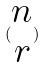<formula> <loc_0><loc_0><loc_500><loc_500>( \begin{matrix} n \\ r \end{matrix} )</formula> 